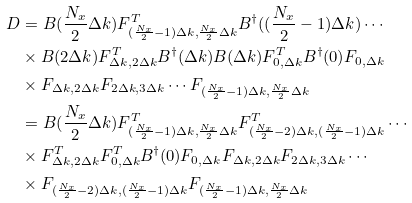<formula> <loc_0><loc_0><loc_500><loc_500>D & = B ( \frac { N _ { x } } { 2 } \Delta k ) F _ { ( \frac { N _ { x } } { 2 } - 1 ) \Delta k , \frac { N _ { x } } { 2 } \Delta k } ^ { T } B ^ { \dagger } ( ( \frac { N _ { x } } { 2 } - 1 ) \Delta k ) \cdots \\ & \times B ( 2 \Delta k ) F _ { \Delta k , 2 \Delta k } ^ { T } B ^ { \dagger } ( \Delta k ) B ( \Delta k ) F _ { 0 , \Delta k } ^ { T } B ^ { \dagger } ( 0 ) F _ { 0 , \Delta k } \\ & \times F _ { \Delta k , 2 \Delta k } F _ { 2 \Delta k , 3 \Delta k } \cdots F _ { ( \frac { N _ { x } } { 2 } - 1 ) \Delta k , \frac { N _ { x } } { 2 } \Delta k } \\ & = B ( \frac { N _ { x } } { 2 } \Delta k ) F _ { ( \frac { N _ { x } } { 2 } - 1 ) \Delta k , \frac { N _ { x } } { 2 } \Delta k } ^ { T } F _ { ( \frac { N _ { x } } { 2 } - 2 ) \Delta k , ( \frac { N _ { x } } { 2 } - 1 ) \Delta k } ^ { T } \cdots \\ & \times F _ { \Delta k , 2 \Delta k } ^ { T } F _ { 0 , \Delta k } ^ { T } B ^ { \dagger } ( 0 ) F _ { 0 , \Delta k } F _ { \Delta k , 2 \Delta k } F _ { 2 \Delta k , 3 \Delta k } \cdots \\ & \times F _ { ( \frac { N _ { x } } { 2 } - 2 ) \Delta k , ( \frac { N _ { x } } { 2 } - 1 ) \Delta k } F _ { ( \frac { N _ { x } } { 2 } - 1 ) \Delta k , \frac { N _ { x } } { 2 } \Delta k }</formula> 